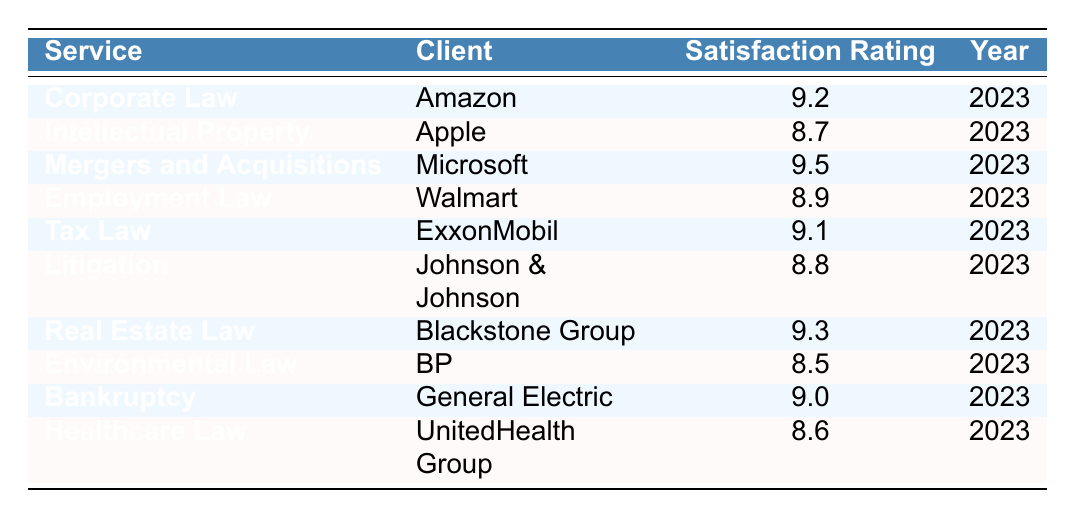What is the satisfaction rating for Mergers and Acquisitions? The table lists the satisfaction rating for Mergers and Acquisitions as 9.5.
Answer: 9.5 Which client has the highest satisfaction rating? By reviewing the satisfaction ratings, Microsoft has the highest rating at 9.5.
Answer: Microsoft What is the average satisfaction rating for all services in 2023? Adding the satisfaction ratings (9.2 + 8.7 + 9.5 + 8.9 + 9.1 + 8.8 + 9.3 + 8.5 + 9.0 + 8.6 = 88.6) and dividing by the number of services (10), the average is 88.6 / 10 = 8.86.
Answer: 8.86 Which services have a satisfaction rating above 9? The services with ratings above 9 are Mergers and Acquisitions (9.5), Real Estate Law (9.3), and Tax Law (9.1).
Answer: Mergers and Acquisitions, Real Estate Law, Tax Law Is the satisfaction rating for Employment Law greater than 9? The table shows that Employment Law has a satisfaction rating of 8.9, which is less than 9.
Answer: No What is the difference between the highest and lowest satisfaction ratings? The highest rating is 9.5 (Mergers and Acquisitions) and the lowest is 8.5 (Environmental Law), so the difference is 9.5 - 8.5 = 1.0.
Answer: 1.0 Which client has the lowest satisfaction rating, and what is it? The table indicates that BP (Environmental Law) has the lowest rating at 8.5.
Answer: BP, 8.5 How many clients have a satisfaction rating of 9 or higher? The clients with ratings of 9 or higher are Amazon, Microsoft, Blackstone Group, and ExxonMobil. That's a total of 4 clients.
Answer: 4 Is there a service with a satisfaction rating of exactly 9? Upon reviewing the table, General Electric with Bankruptcy has a satisfaction rating of exactly 9.
Answer: Yes What is the total satisfaction rating across all listed services? The total is calculated by summing all ratings (9.2 + 8.7 + 9.5 + 8.9 + 9.1 + 8.8 + 9.3 + 8.5 + 9.0 + 8.6 = 88.6).
Answer: 88.6 